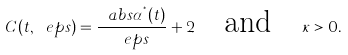Convert formula to latex. <formula><loc_0><loc_0><loc_500><loc_500>C ( t , \ e p s ) = \frac { \ a b s { \alpha ^ { ^ { * } } ( t ) } } { \ e p s } + 2 \quad \text {and} \quad \kappa > 0 .</formula> 